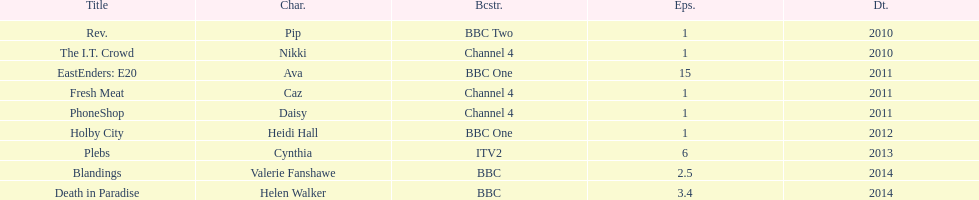What was the previous role this actress played before playing cynthia in plebs? Heidi Hall. 